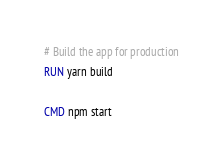<code> <loc_0><loc_0><loc_500><loc_500><_Dockerfile_>
# Build the app for production
RUN yarn build

CMD npm start


</code> 